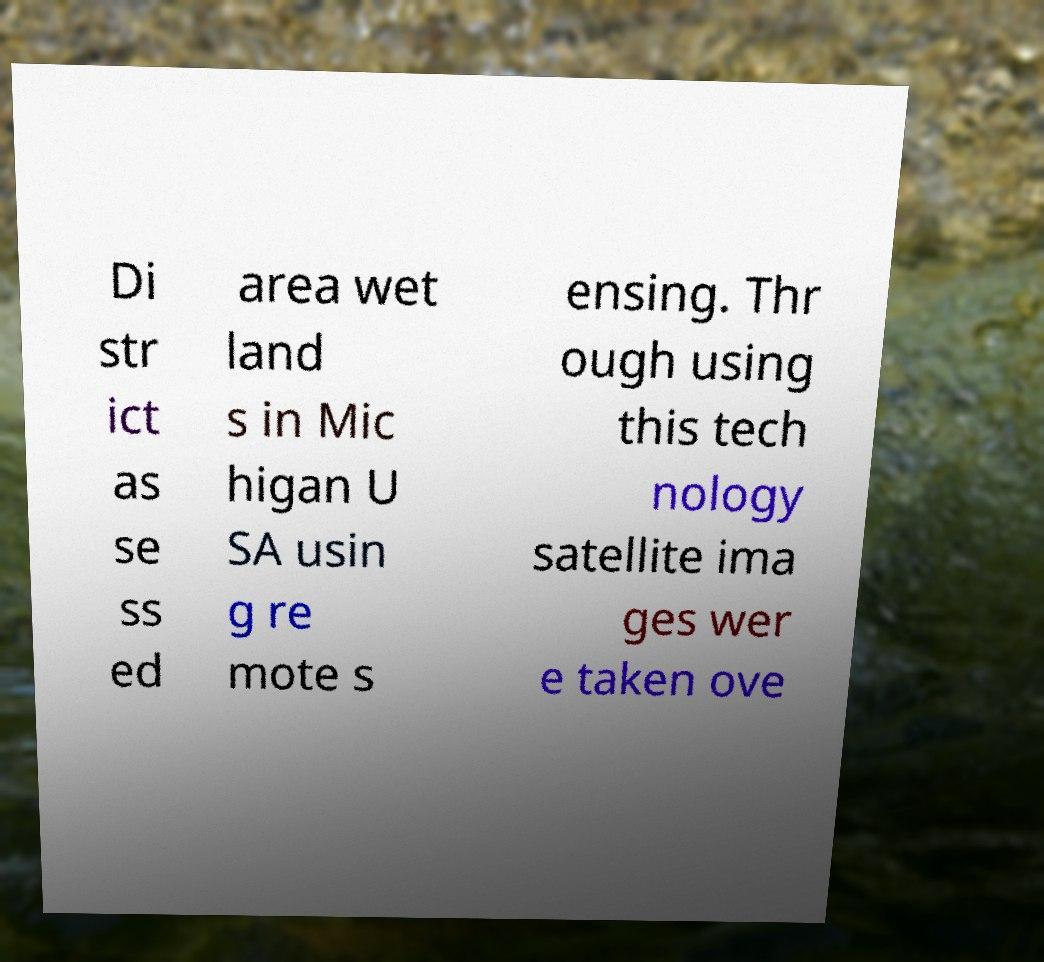Can you accurately transcribe the text from the provided image for me? Di str ict as se ss ed area wet land s in Mic higan U SA usin g re mote s ensing. Thr ough using this tech nology satellite ima ges wer e taken ove 